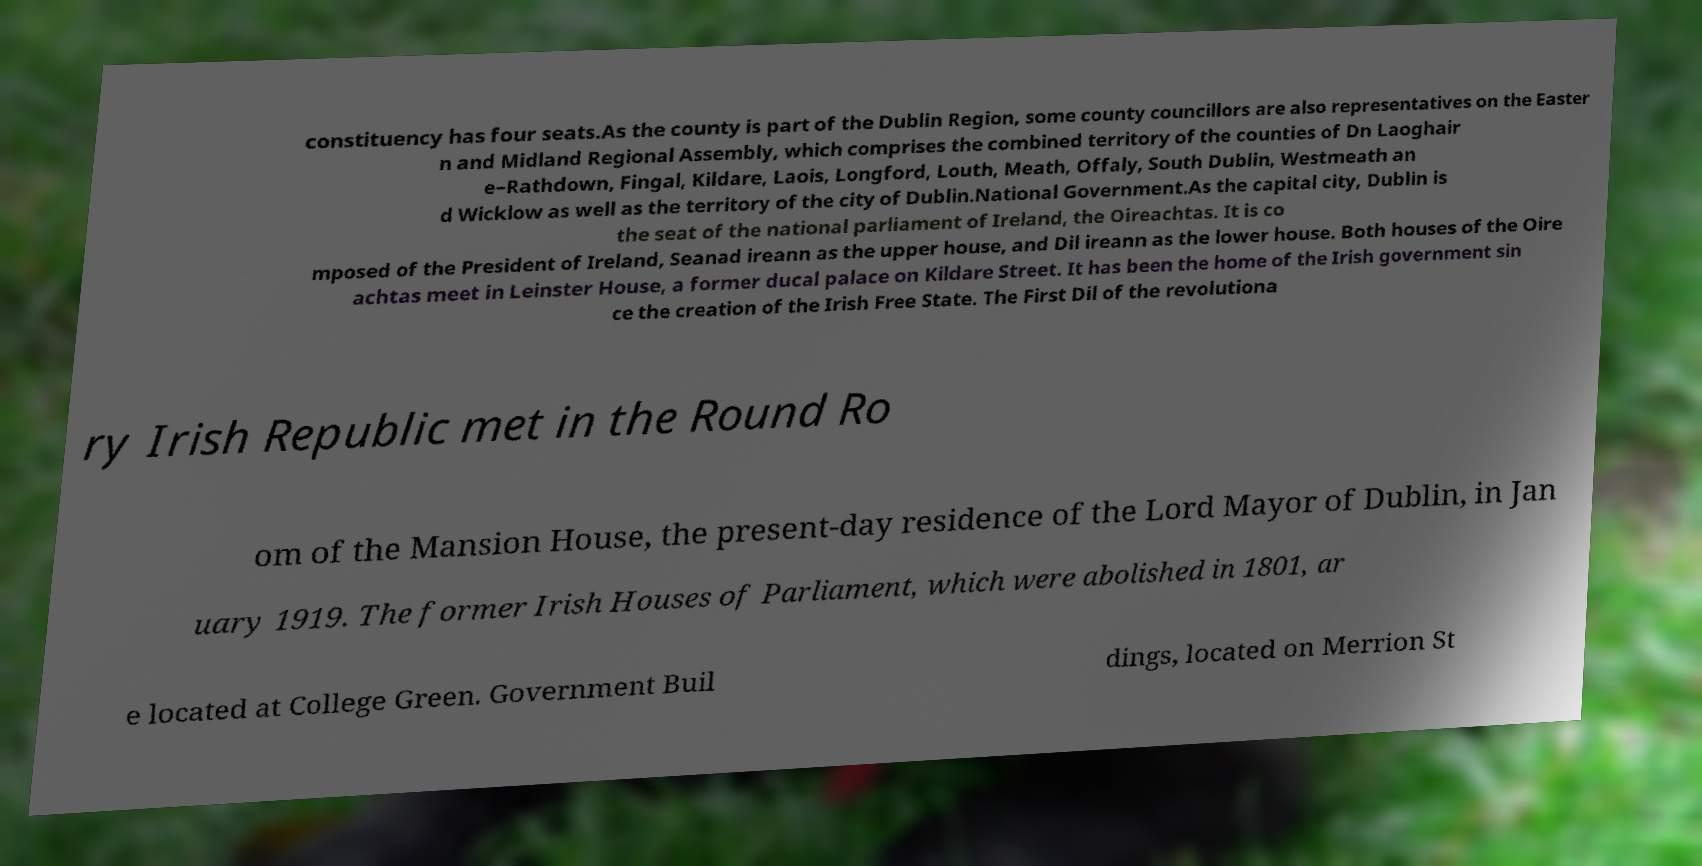Could you assist in decoding the text presented in this image and type it out clearly? constituency has four seats.As the county is part of the Dublin Region, some county councillors are also representatives on the Easter n and Midland Regional Assembly, which comprises the combined territory of the counties of Dn Laoghair e–Rathdown, Fingal, Kildare, Laois, Longford, Louth, Meath, Offaly, South Dublin, Westmeath an d Wicklow as well as the territory of the city of Dublin.National Government.As the capital city, Dublin is the seat of the national parliament of Ireland, the Oireachtas. It is co mposed of the President of Ireland, Seanad ireann as the upper house, and Dil ireann as the lower house. Both houses of the Oire achtas meet in Leinster House, a former ducal palace on Kildare Street. It has been the home of the Irish government sin ce the creation of the Irish Free State. The First Dil of the revolutiona ry Irish Republic met in the Round Ro om of the Mansion House, the present-day residence of the Lord Mayor of Dublin, in Jan uary 1919. The former Irish Houses of Parliament, which were abolished in 1801, ar e located at College Green. Government Buil dings, located on Merrion St 